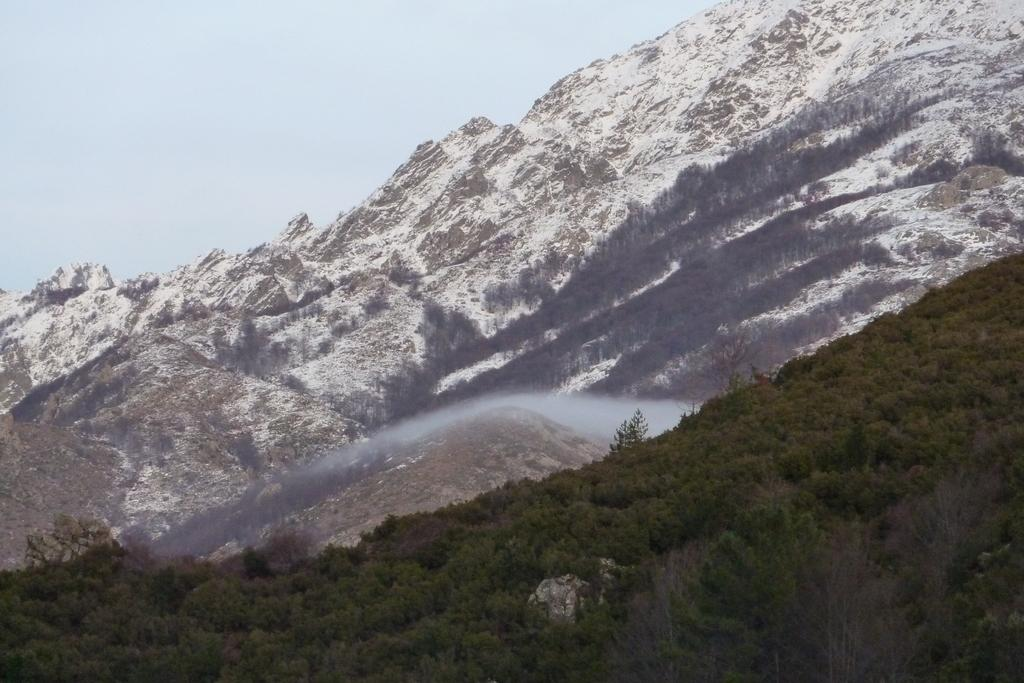What type of vegetation is present at the bottom of the image? There are trees at the bottom side of the image. What type of geographical feature can be seen in the background of the image? There are mountains in the background area of the image. Where is the basket located in the image? There is no basket present in the image. What type of amphibian can be seen near the trees in the image? There are no amphibians, such as toads, present in the image. 